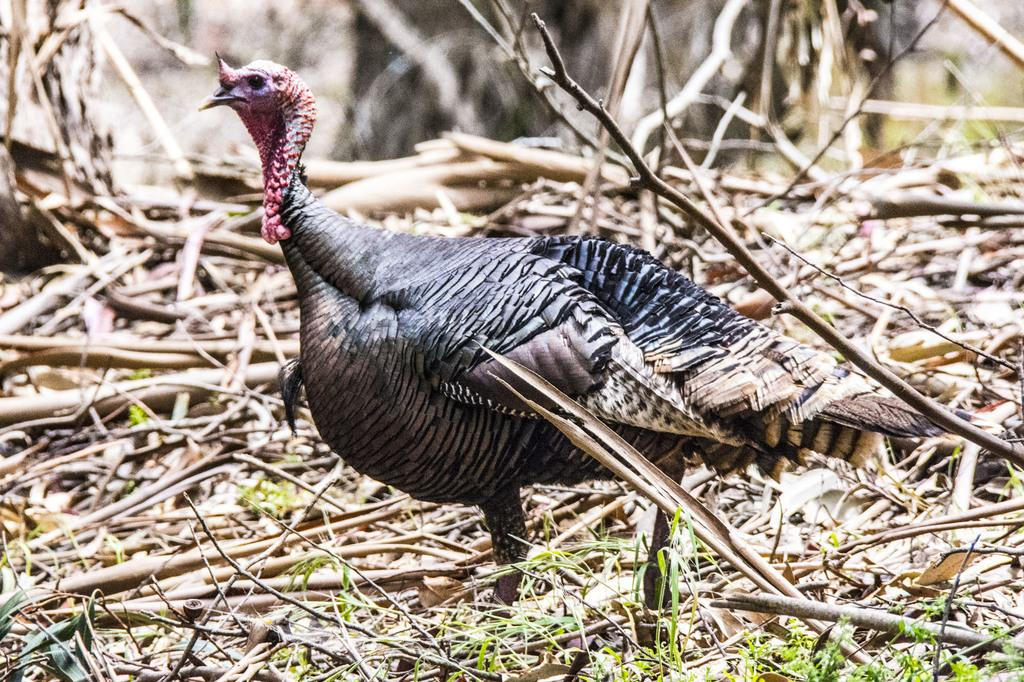What is the main focus of the image? The image is mainly highlighted by a turkey bird. How would you describe the ground in the image? There is green grass on the ground, and there are also twigs present. What can be observed about the background of the image? The background portion of the picture is blurred. What type of toy can be seen in the image? There is no toy present in the image; it mainly features a turkey bird. What is the temperature of the hot item in the image? There is no hot item present in the image. 